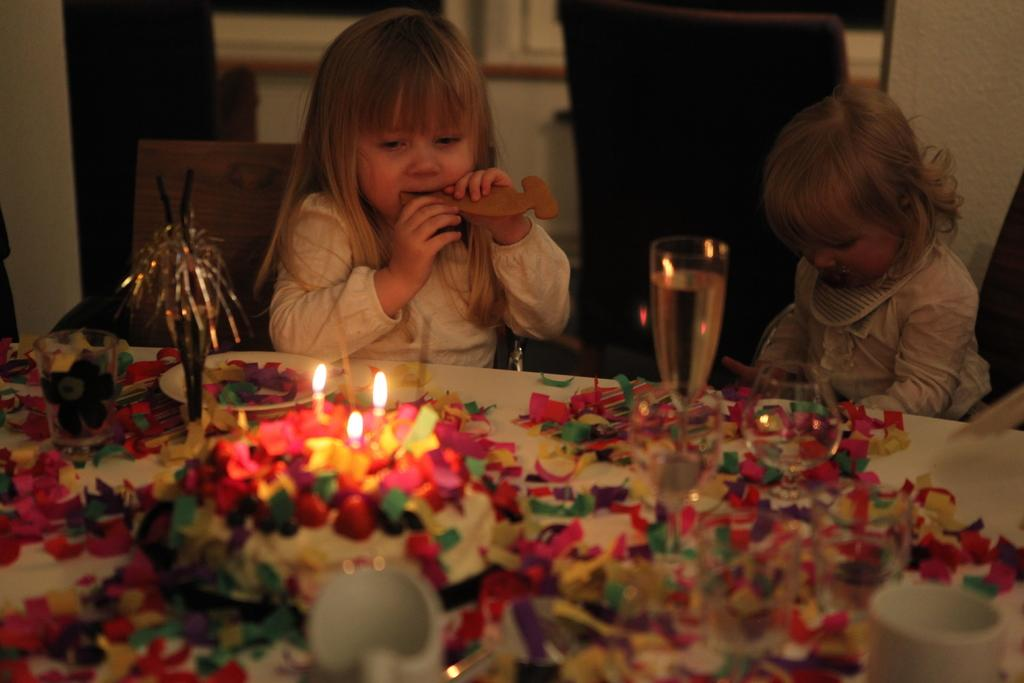How many kids are in the image? There are two kids in the image. What are the kids doing in the image? The kids are sitting in chairs. What is in front of the kids? There is a table in front of the kids. What can be seen on the table? There are glasses, a cake, and candles on the table. Are there any other objects on the table? Yes, there are other objects on the table. What is the digestion process of the cake in the image? The image does not show the digestion process of the cake, as it only depicts the cake on the table. What day is it in the image? The image does not provide any information about the day, as it only shows the kids, table, and objects. 